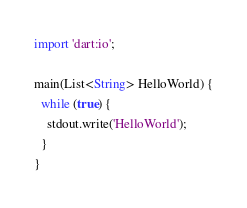Convert code to text. <code><loc_0><loc_0><loc_500><loc_500><_Dart_>import 'dart:io';

main(List<String> HelloWorld) {
  while (true) {
    stdout.write('HelloWorld');
  }
}</code> 